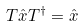<formula> <loc_0><loc_0><loc_500><loc_500>T \hat { x } T ^ { \dagger } = \hat { x }</formula> 